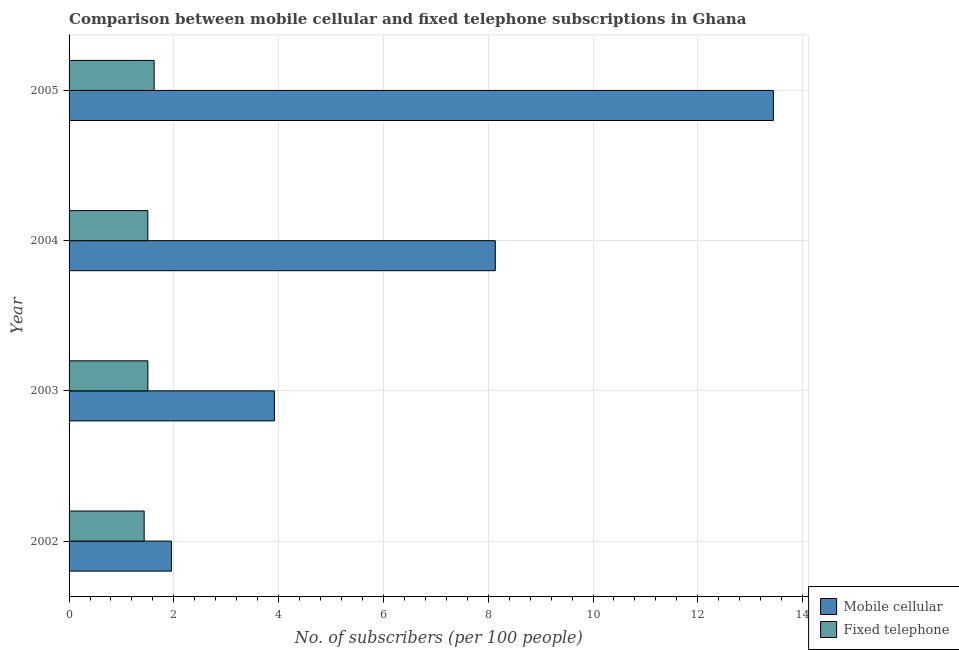Are the number of bars per tick equal to the number of legend labels?
Your response must be concise. Yes. How many bars are there on the 3rd tick from the bottom?
Provide a short and direct response. 2. What is the number of fixed telephone subscribers in 2002?
Keep it short and to the point. 1.43. Across all years, what is the maximum number of mobile cellular subscribers?
Ensure brevity in your answer.  13.44. Across all years, what is the minimum number of mobile cellular subscribers?
Provide a short and direct response. 1.95. What is the total number of mobile cellular subscribers in the graph?
Your answer should be compact. 27.45. What is the difference between the number of fixed telephone subscribers in 2002 and that in 2003?
Keep it short and to the point. -0.07. What is the difference between the number of mobile cellular subscribers in 2004 and the number of fixed telephone subscribers in 2003?
Keep it short and to the point. 6.63. What is the average number of fixed telephone subscribers per year?
Provide a succinct answer. 1.52. In the year 2004, what is the difference between the number of mobile cellular subscribers and number of fixed telephone subscribers?
Your response must be concise. 6.63. In how many years, is the number of fixed telephone subscribers greater than 1.2000000000000002 ?
Your answer should be very brief. 4. What is the ratio of the number of fixed telephone subscribers in 2002 to that in 2005?
Make the answer very short. 0.88. Is the difference between the number of mobile cellular subscribers in 2003 and 2004 greater than the difference between the number of fixed telephone subscribers in 2003 and 2004?
Provide a succinct answer. No. What is the difference between the highest and the second highest number of mobile cellular subscribers?
Offer a very short reply. 5.31. What is the difference between the highest and the lowest number of fixed telephone subscribers?
Provide a short and direct response. 0.19. What does the 1st bar from the top in 2004 represents?
Your answer should be compact. Fixed telephone. What does the 2nd bar from the bottom in 2002 represents?
Your answer should be compact. Fixed telephone. How many bars are there?
Provide a short and direct response. 8. How many years are there in the graph?
Provide a succinct answer. 4. Does the graph contain any zero values?
Offer a terse response. No. Does the graph contain grids?
Make the answer very short. Yes. How many legend labels are there?
Your answer should be very brief. 2. How are the legend labels stacked?
Provide a short and direct response. Vertical. What is the title of the graph?
Give a very brief answer. Comparison between mobile cellular and fixed telephone subscriptions in Ghana. Does "Mineral" appear as one of the legend labels in the graph?
Make the answer very short. No. What is the label or title of the X-axis?
Offer a terse response. No. of subscribers (per 100 people). What is the label or title of the Y-axis?
Offer a very short reply. Year. What is the No. of subscribers (per 100 people) in Mobile cellular in 2002?
Offer a terse response. 1.95. What is the No. of subscribers (per 100 people) of Fixed telephone in 2002?
Offer a very short reply. 1.43. What is the No. of subscribers (per 100 people) in Mobile cellular in 2003?
Provide a succinct answer. 3.92. What is the No. of subscribers (per 100 people) in Fixed telephone in 2003?
Your answer should be very brief. 1.5. What is the No. of subscribers (per 100 people) in Mobile cellular in 2004?
Provide a short and direct response. 8.14. What is the No. of subscribers (per 100 people) in Fixed telephone in 2004?
Provide a short and direct response. 1.5. What is the No. of subscribers (per 100 people) in Mobile cellular in 2005?
Offer a very short reply. 13.44. What is the No. of subscribers (per 100 people) in Fixed telephone in 2005?
Provide a succinct answer. 1.62. Across all years, what is the maximum No. of subscribers (per 100 people) of Mobile cellular?
Give a very brief answer. 13.44. Across all years, what is the maximum No. of subscribers (per 100 people) of Fixed telephone?
Give a very brief answer. 1.62. Across all years, what is the minimum No. of subscribers (per 100 people) of Mobile cellular?
Provide a succinct answer. 1.95. Across all years, what is the minimum No. of subscribers (per 100 people) of Fixed telephone?
Keep it short and to the point. 1.43. What is the total No. of subscribers (per 100 people) in Mobile cellular in the graph?
Offer a very short reply. 27.45. What is the total No. of subscribers (per 100 people) in Fixed telephone in the graph?
Provide a succinct answer. 6.06. What is the difference between the No. of subscribers (per 100 people) in Mobile cellular in 2002 and that in 2003?
Offer a very short reply. -1.96. What is the difference between the No. of subscribers (per 100 people) in Fixed telephone in 2002 and that in 2003?
Provide a short and direct response. -0.07. What is the difference between the No. of subscribers (per 100 people) of Mobile cellular in 2002 and that in 2004?
Give a very brief answer. -6.18. What is the difference between the No. of subscribers (per 100 people) in Fixed telephone in 2002 and that in 2004?
Provide a short and direct response. -0.07. What is the difference between the No. of subscribers (per 100 people) in Mobile cellular in 2002 and that in 2005?
Provide a succinct answer. -11.49. What is the difference between the No. of subscribers (per 100 people) in Fixed telephone in 2002 and that in 2005?
Keep it short and to the point. -0.19. What is the difference between the No. of subscribers (per 100 people) of Mobile cellular in 2003 and that in 2004?
Provide a short and direct response. -4.22. What is the difference between the No. of subscribers (per 100 people) of Fixed telephone in 2003 and that in 2004?
Your answer should be compact. 0. What is the difference between the No. of subscribers (per 100 people) of Mobile cellular in 2003 and that in 2005?
Your answer should be very brief. -9.52. What is the difference between the No. of subscribers (per 100 people) in Fixed telephone in 2003 and that in 2005?
Your response must be concise. -0.12. What is the difference between the No. of subscribers (per 100 people) in Mobile cellular in 2004 and that in 2005?
Offer a very short reply. -5.31. What is the difference between the No. of subscribers (per 100 people) in Fixed telephone in 2004 and that in 2005?
Ensure brevity in your answer.  -0.12. What is the difference between the No. of subscribers (per 100 people) in Mobile cellular in 2002 and the No. of subscribers (per 100 people) in Fixed telephone in 2003?
Your response must be concise. 0.45. What is the difference between the No. of subscribers (per 100 people) of Mobile cellular in 2002 and the No. of subscribers (per 100 people) of Fixed telephone in 2004?
Offer a terse response. 0.45. What is the difference between the No. of subscribers (per 100 people) of Mobile cellular in 2002 and the No. of subscribers (per 100 people) of Fixed telephone in 2005?
Provide a short and direct response. 0.33. What is the difference between the No. of subscribers (per 100 people) of Mobile cellular in 2003 and the No. of subscribers (per 100 people) of Fixed telephone in 2004?
Keep it short and to the point. 2.42. What is the difference between the No. of subscribers (per 100 people) of Mobile cellular in 2003 and the No. of subscribers (per 100 people) of Fixed telephone in 2005?
Provide a succinct answer. 2.29. What is the difference between the No. of subscribers (per 100 people) in Mobile cellular in 2004 and the No. of subscribers (per 100 people) in Fixed telephone in 2005?
Keep it short and to the point. 6.51. What is the average No. of subscribers (per 100 people) of Mobile cellular per year?
Make the answer very short. 6.86. What is the average No. of subscribers (per 100 people) in Fixed telephone per year?
Your answer should be very brief. 1.52. In the year 2002, what is the difference between the No. of subscribers (per 100 people) in Mobile cellular and No. of subscribers (per 100 people) in Fixed telephone?
Provide a succinct answer. 0.52. In the year 2003, what is the difference between the No. of subscribers (per 100 people) of Mobile cellular and No. of subscribers (per 100 people) of Fixed telephone?
Offer a very short reply. 2.41. In the year 2004, what is the difference between the No. of subscribers (per 100 people) of Mobile cellular and No. of subscribers (per 100 people) of Fixed telephone?
Keep it short and to the point. 6.63. In the year 2005, what is the difference between the No. of subscribers (per 100 people) in Mobile cellular and No. of subscribers (per 100 people) in Fixed telephone?
Your answer should be very brief. 11.82. What is the ratio of the No. of subscribers (per 100 people) in Mobile cellular in 2002 to that in 2003?
Your answer should be very brief. 0.5. What is the ratio of the No. of subscribers (per 100 people) of Fixed telephone in 2002 to that in 2003?
Your answer should be compact. 0.95. What is the ratio of the No. of subscribers (per 100 people) in Mobile cellular in 2002 to that in 2004?
Give a very brief answer. 0.24. What is the ratio of the No. of subscribers (per 100 people) of Fixed telephone in 2002 to that in 2004?
Keep it short and to the point. 0.95. What is the ratio of the No. of subscribers (per 100 people) in Mobile cellular in 2002 to that in 2005?
Your response must be concise. 0.15. What is the ratio of the No. of subscribers (per 100 people) of Fixed telephone in 2002 to that in 2005?
Ensure brevity in your answer.  0.88. What is the ratio of the No. of subscribers (per 100 people) in Mobile cellular in 2003 to that in 2004?
Provide a succinct answer. 0.48. What is the ratio of the No. of subscribers (per 100 people) of Mobile cellular in 2003 to that in 2005?
Provide a succinct answer. 0.29. What is the ratio of the No. of subscribers (per 100 people) of Fixed telephone in 2003 to that in 2005?
Provide a succinct answer. 0.93. What is the ratio of the No. of subscribers (per 100 people) in Mobile cellular in 2004 to that in 2005?
Make the answer very short. 0.61. What is the ratio of the No. of subscribers (per 100 people) in Fixed telephone in 2004 to that in 2005?
Your response must be concise. 0.93. What is the difference between the highest and the second highest No. of subscribers (per 100 people) of Mobile cellular?
Your answer should be compact. 5.31. What is the difference between the highest and the second highest No. of subscribers (per 100 people) in Fixed telephone?
Ensure brevity in your answer.  0.12. What is the difference between the highest and the lowest No. of subscribers (per 100 people) in Mobile cellular?
Your answer should be compact. 11.49. What is the difference between the highest and the lowest No. of subscribers (per 100 people) in Fixed telephone?
Make the answer very short. 0.19. 